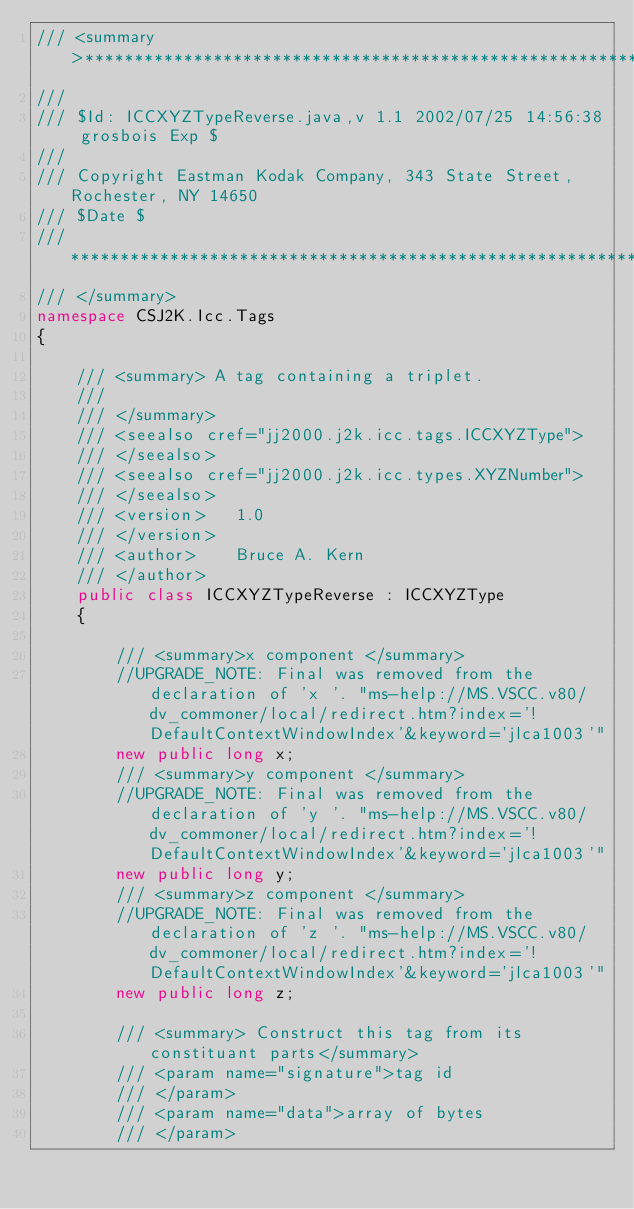Convert code to text. <code><loc_0><loc_0><loc_500><loc_500><_C#_>/// <summary>**************************************************************************
/// 
/// $Id: ICCXYZTypeReverse.java,v 1.1 2002/07/25 14:56:38 grosbois Exp $
/// 
/// Copyright Eastman Kodak Company, 343 State Street, Rochester, NY 14650
/// $Date $
/// ***************************************************************************
/// </summary>
namespace CSJ2K.Icc.Tags
{

    /// <summary> A tag containing a triplet.
    /// 
    /// </summary>
    /// <seealso cref="jj2000.j2k.icc.tags.ICCXYZType">
    /// </seealso>
    /// <seealso cref="jj2000.j2k.icc.types.XYZNumber">
    /// </seealso>
    /// <version> 	1.0
    /// </version>
    /// <author> 	Bruce A. Kern
    /// </author>
    public class ICCXYZTypeReverse : ICCXYZType
    {

        /// <summary>x component </summary>
        //UPGRADE_NOTE: Final was removed from the declaration of 'x '. "ms-help://MS.VSCC.v80/dv_commoner/local/redirect.htm?index='!DefaultContextWindowIndex'&keyword='jlca1003'"
        new public long x;
        /// <summary>y component </summary>
        //UPGRADE_NOTE: Final was removed from the declaration of 'y '. "ms-help://MS.VSCC.v80/dv_commoner/local/redirect.htm?index='!DefaultContextWindowIndex'&keyword='jlca1003'"
        new public long y;
        /// <summary>z component </summary>
        //UPGRADE_NOTE: Final was removed from the declaration of 'z '. "ms-help://MS.VSCC.v80/dv_commoner/local/redirect.htm?index='!DefaultContextWindowIndex'&keyword='jlca1003'"
        new public long z;

        /// <summary> Construct this tag from its constituant parts</summary>
        /// <param name="signature">tag id
        /// </param>
        /// <param name="data">array of bytes
        /// </param></code> 